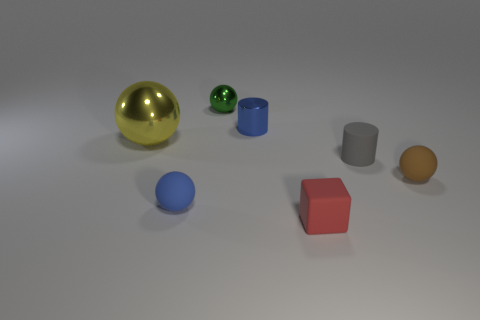The blue thing that is the same shape as the small gray matte object is what size?
Offer a very short reply. Small. There is a tiny matte thing left of the small blue metallic object; does it have the same shape as the red object?
Provide a succinct answer. No. There is a small cylinder right of the red matte cube; what is its color?
Provide a succinct answer. Gray. How many other objects are there of the same size as the brown rubber object?
Your response must be concise. 5. Are there any other things that are the same shape as the brown thing?
Your answer should be compact. Yes. Are there the same number of brown objects that are left of the green object and gray matte things?
Offer a terse response. No. What number of balls have the same material as the tiny blue cylinder?
Your answer should be compact. 2. The small block that is made of the same material as the tiny brown sphere is what color?
Ensure brevity in your answer.  Red. Does the red thing have the same shape as the gray rubber thing?
Your answer should be compact. No. Are there any blue objects that are on the right side of the blue rubber thing left of the tiny sphere on the right side of the red rubber thing?
Provide a short and direct response. Yes. 